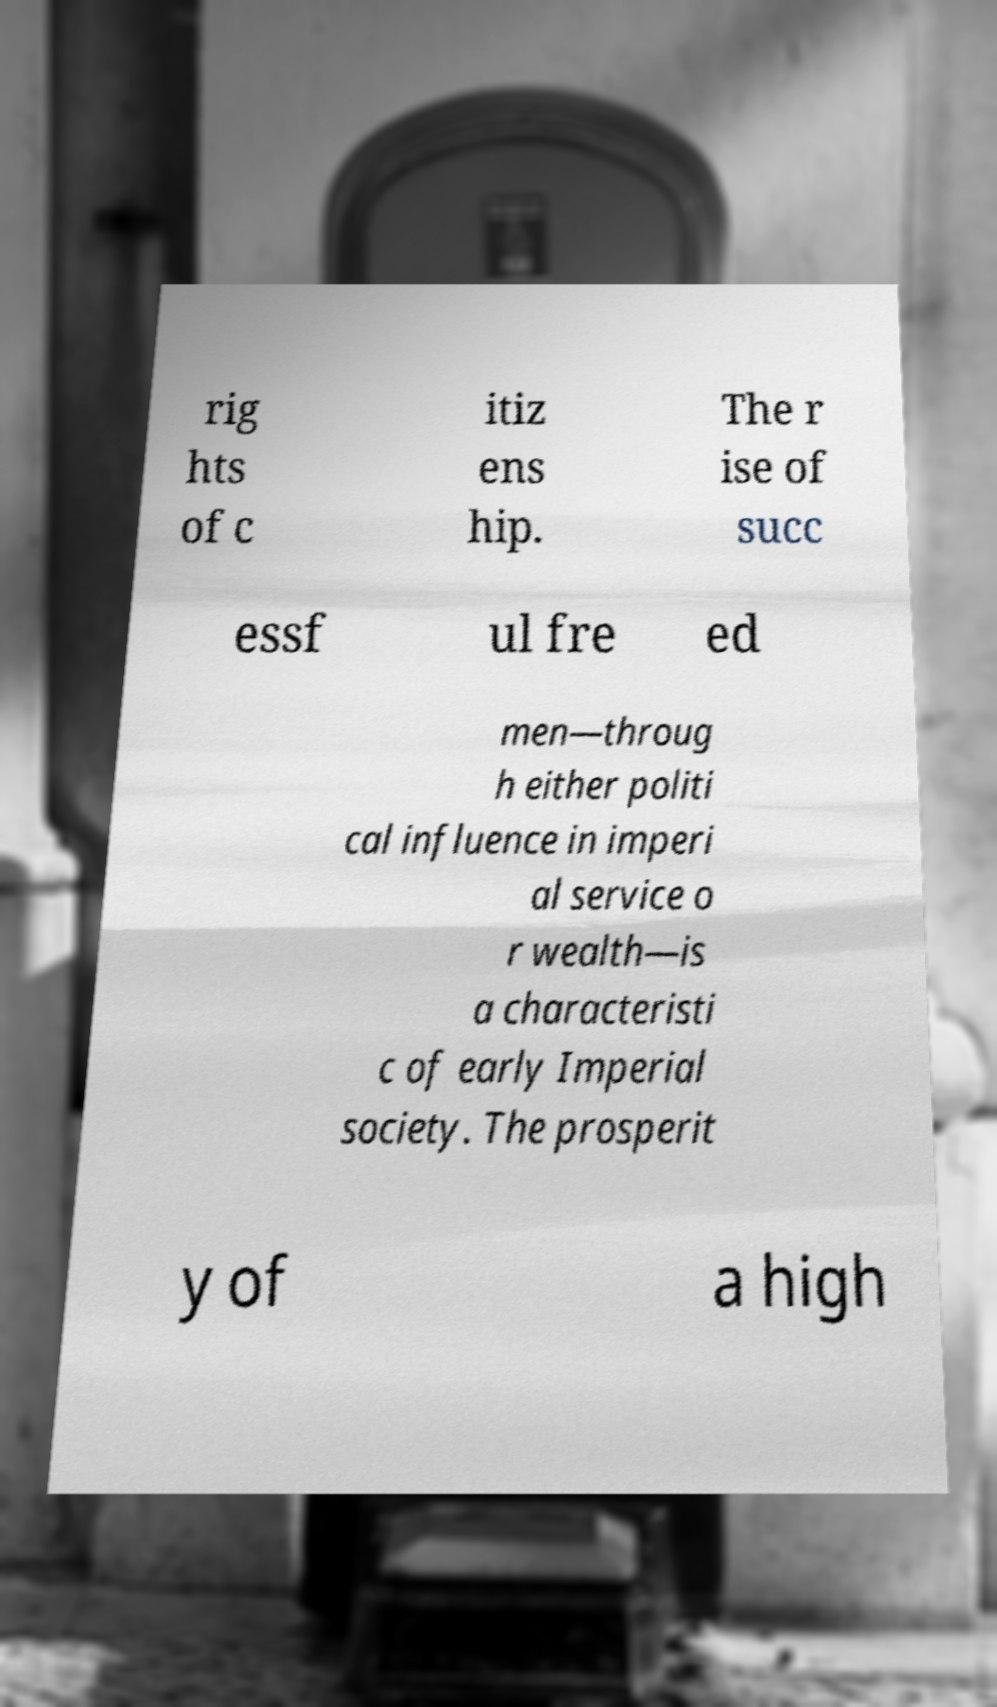Could you extract and type out the text from this image? rig hts of c itiz ens hip. The r ise of succ essf ul fre ed men—throug h either politi cal influence in imperi al service o r wealth—is a characteristi c of early Imperial society. The prosperit y of a high 